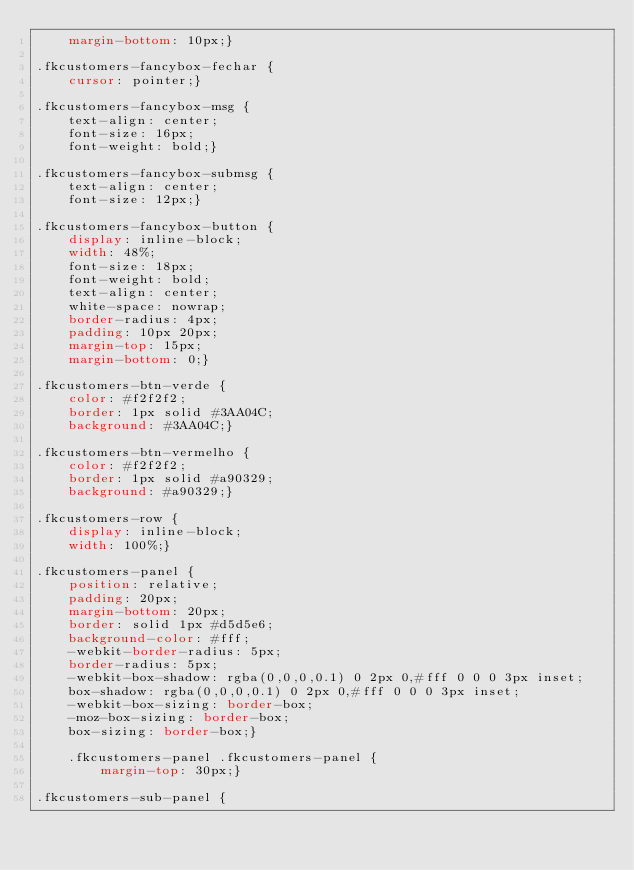<code> <loc_0><loc_0><loc_500><loc_500><_CSS_>    margin-bottom: 10px;}

.fkcustomers-fancybox-fechar {
    cursor: pointer;}

.fkcustomers-fancybox-msg {
    text-align: center;
    font-size: 16px;
    font-weight: bold;}

.fkcustomers-fancybox-submsg {
    text-align: center;
    font-size: 12px;}

.fkcustomers-fancybox-button {
    display: inline-block;
    width: 48%;
    font-size: 18px;
    font-weight: bold;
    text-align: center;
    white-space: nowrap;
    border-radius: 4px;
    padding: 10px 20px;
    margin-top: 15px;
    margin-bottom: 0;}

.fkcustomers-btn-verde {
    color: #f2f2f2;
    border: 1px solid #3AA04C;
    background: #3AA04C;}

.fkcustomers-btn-vermelho {
    color: #f2f2f2;
    border: 1px solid #a90329;
    background: #a90329;}

.fkcustomers-row {
    display: inline-block;
    width: 100%;}
    
.fkcustomers-panel {
    position: relative;
    padding: 20px;
    margin-bottom: 20px;
    border: solid 1px #d5d5e6;
    background-color: #fff;
    -webkit-border-radius: 5px;
    border-radius: 5px;
    -webkit-box-shadow: rgba(0,0,0,0.1) 0 2px 0,#fff 0 0 0 3px inset;
    box-shadow: rgba(0,0,0,0.1) 0 2px 0,#fff 0 0 0 3px inset;
    -webkit-box-sizing: border-box;
    -moz-box-sizing: border-box;
    box-sizing: border-box;}
    
    .fkcustomers-panel .fkcustomers-panel {
        margin-top: 30px;}

.fkcustomers-sub-panel {</code> 